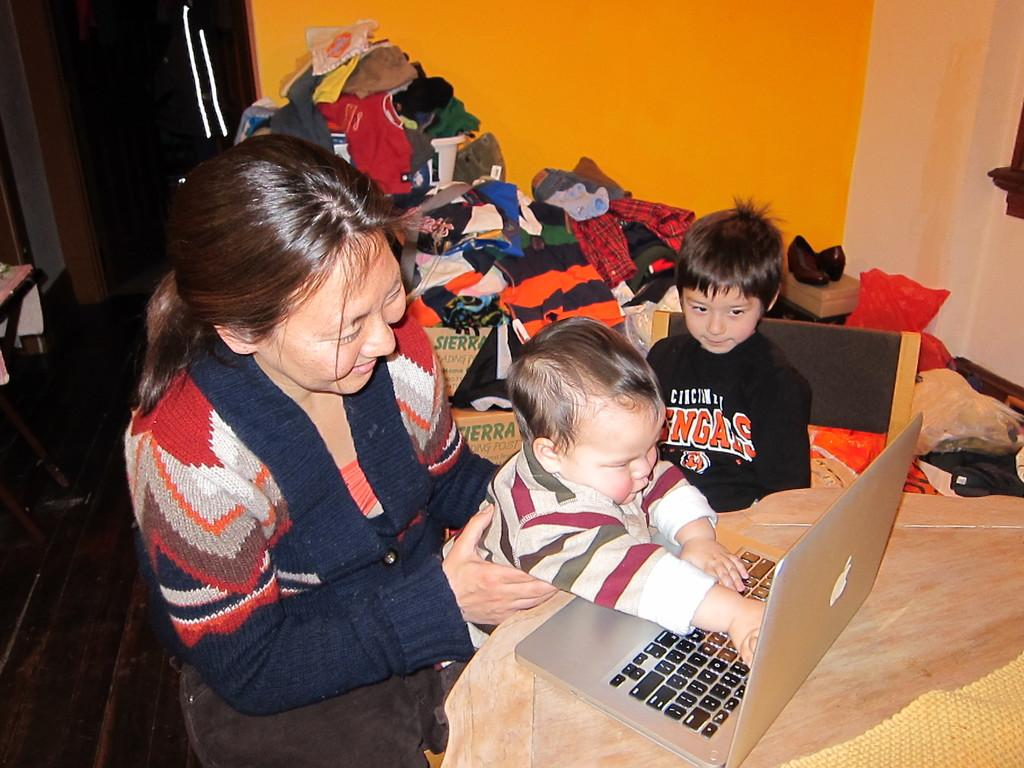Who are the individuals in the image? There is a woman, a baby, and a boy in the image. What are they doing in the image? The three individuals are sitting in a chair. What object can be seen on a table in the image? There is a laptop on a table in the image. What can be seen in the background of the image? There are clothes and a wall visible in the background. How many pizzas are being held by the woman's finger in the image? There are no pizzas or fingers visible in the image. 